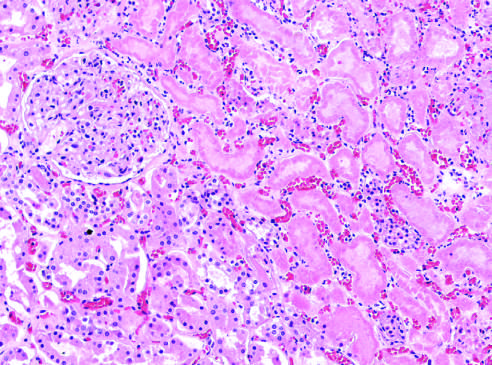what show preserved outlines with loss of nuclei?
Answer the question using a single word or phrase. The necrotic cells 